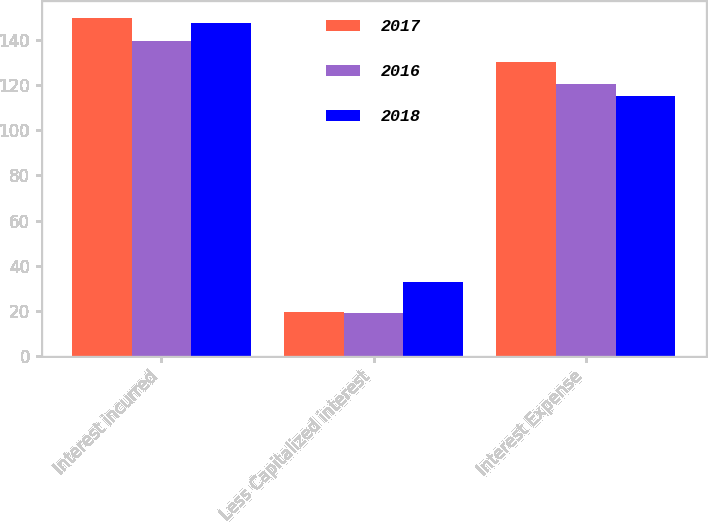<chart> <loc_0><loc_0><loc_500><loc_500><stacked_bar_chart><ecel><fcel>Interest incurred<fcel>Less Capitalized interest<fcel>Interest Expense<nl><fcel>2017<fcel>150<fcel>19.5<fcel>130.5<nl><fcel>2016<fcel>139.6<fcel>19<fcel>120.6<nl><fcel>2018<fcel>147.9<fcel>32.7<fcel>115.2<nl></chart> 